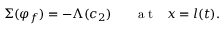<formula> <loc_0><loc_0><loc_500><loc_500>\Sigma ( \varphi _ { f } ) = - \Lambda ( c _ { 2 } ) a t x = l ( t ) .</formula> 